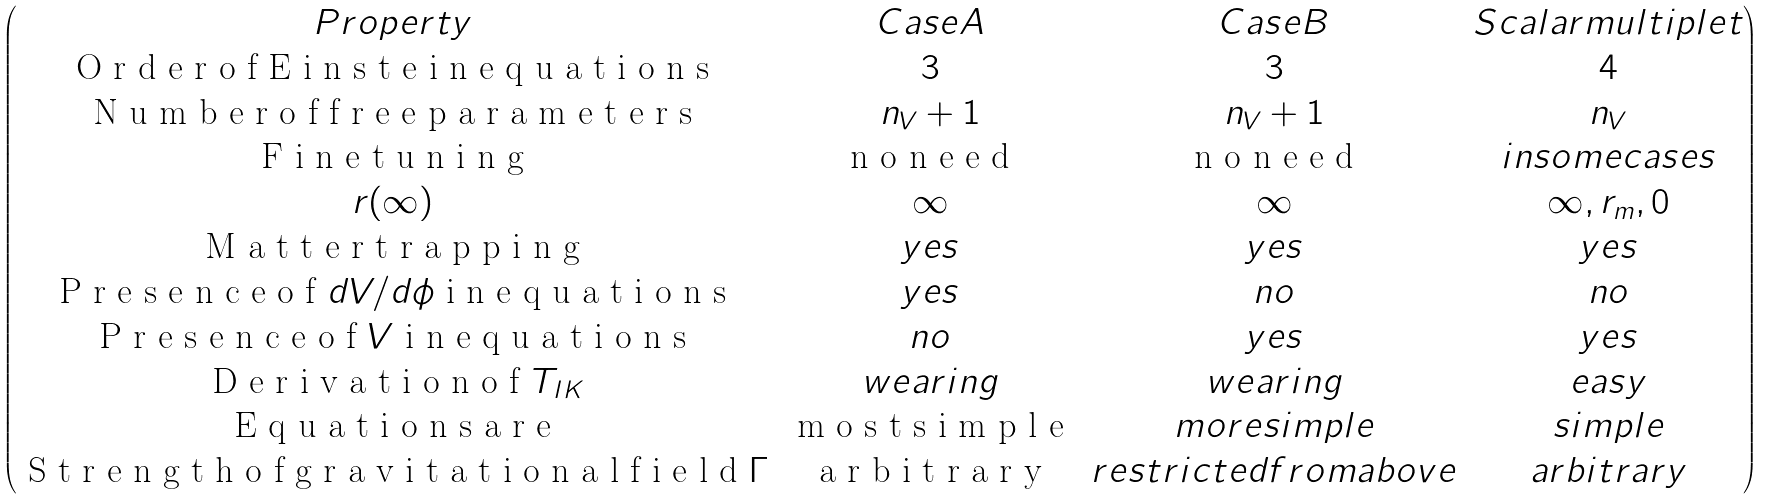Convert formula to latex. <formula><loc_0><loc_0><loc_500><loc_500>\begin{pmatrix} P r o p e r t y & C a s e A & C a s e B & S c a l a r m u l t i p l e t \\ $ O r d e r o f E i n s t e i n e q u a t i o n s $ & 3 & 3 & 4 \\ $ N u m b e r o f f r e e p a r a m e t e r s $ & n _ { V } + 1 & n _ { V } + 1 & n _ { V } \\ $ F i n e t u n i n g $ & $ n o n e e d $ & $ n o n e e d $ & i n s o m e c a s e s \\ r ( \infty ) & \infty & \infty & \infty , r _ { m } , 0 \\ $ M a t t e r t r a p p i n g $ & y e s & y e s & y e s \\ $ P r e s e n c e o f $ d V / d \phi $ i n e q u a t i o n s $ & y e s & n o & n o \\ $ P r e s e n c e o f $ V $ i n e q u a t i o n s $ & n o & y e s & y e s \\ $ D e r i v a t i o n o f $ T _ { I K } & w e a r i n g & w e a r i n g & e a s y \\ $ E q u a t i o n s a r e $ & $ m o s t s i m p l e $ & m o r e s i m p l e & s i m p l e \\ $ S t r e n g t h o f g r a v i t a t i o n a l f i e l d $ \Gamma & $ a r b i t r a r y $ & r e s t r i c t e d f r o m a b o v e & a r b i t r a r y \\ \end{pmatrix}</formula> 